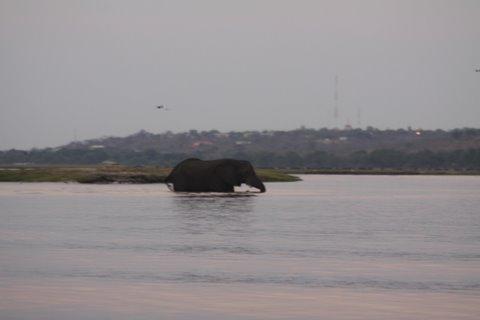How many cars are to the right?
Give a very brief answer. 0. 